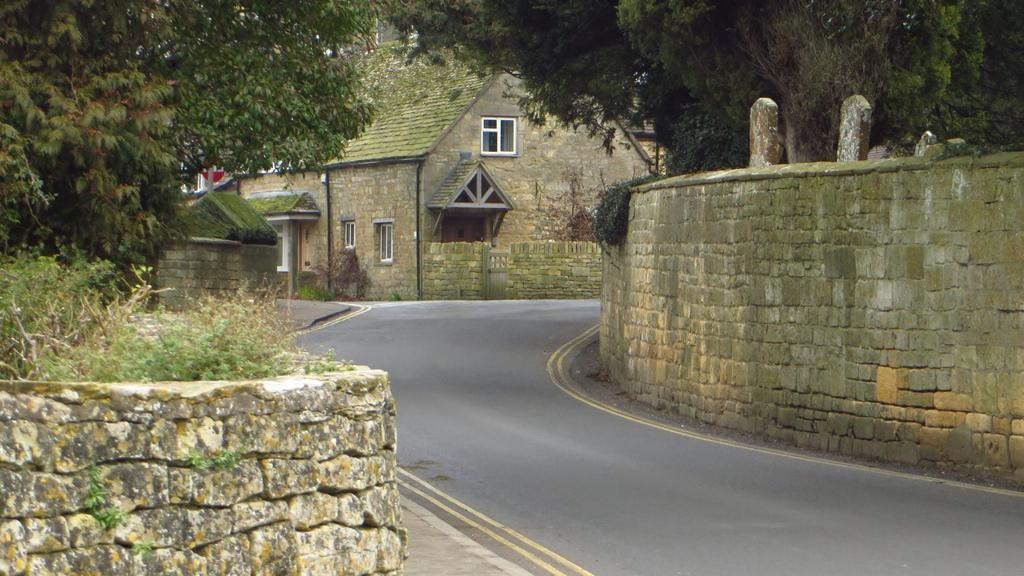What type of natural elements can be seen in the image? There are plants and trees visible in the image. What type of man-made structures can be seen in the image? There are walls, a road, houses, a fence, a gate, and roofs visible in the image. What additional features can be seen in the background of the image? There are windows, a fence, a gate, roofs, and a sign board visible in the background. What type of wire is holding the earth in the image? There is no wire or earth present in the image. How many fingers can be seen pointing at the sign board in the image? There are no fingers visible in the image. 